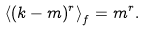<formula> <loc_0><loc_0><loc_500><loc_500>\left < ( k - m ) ^ { r } \right > _ { f } = m ^ { r } .</formula> 